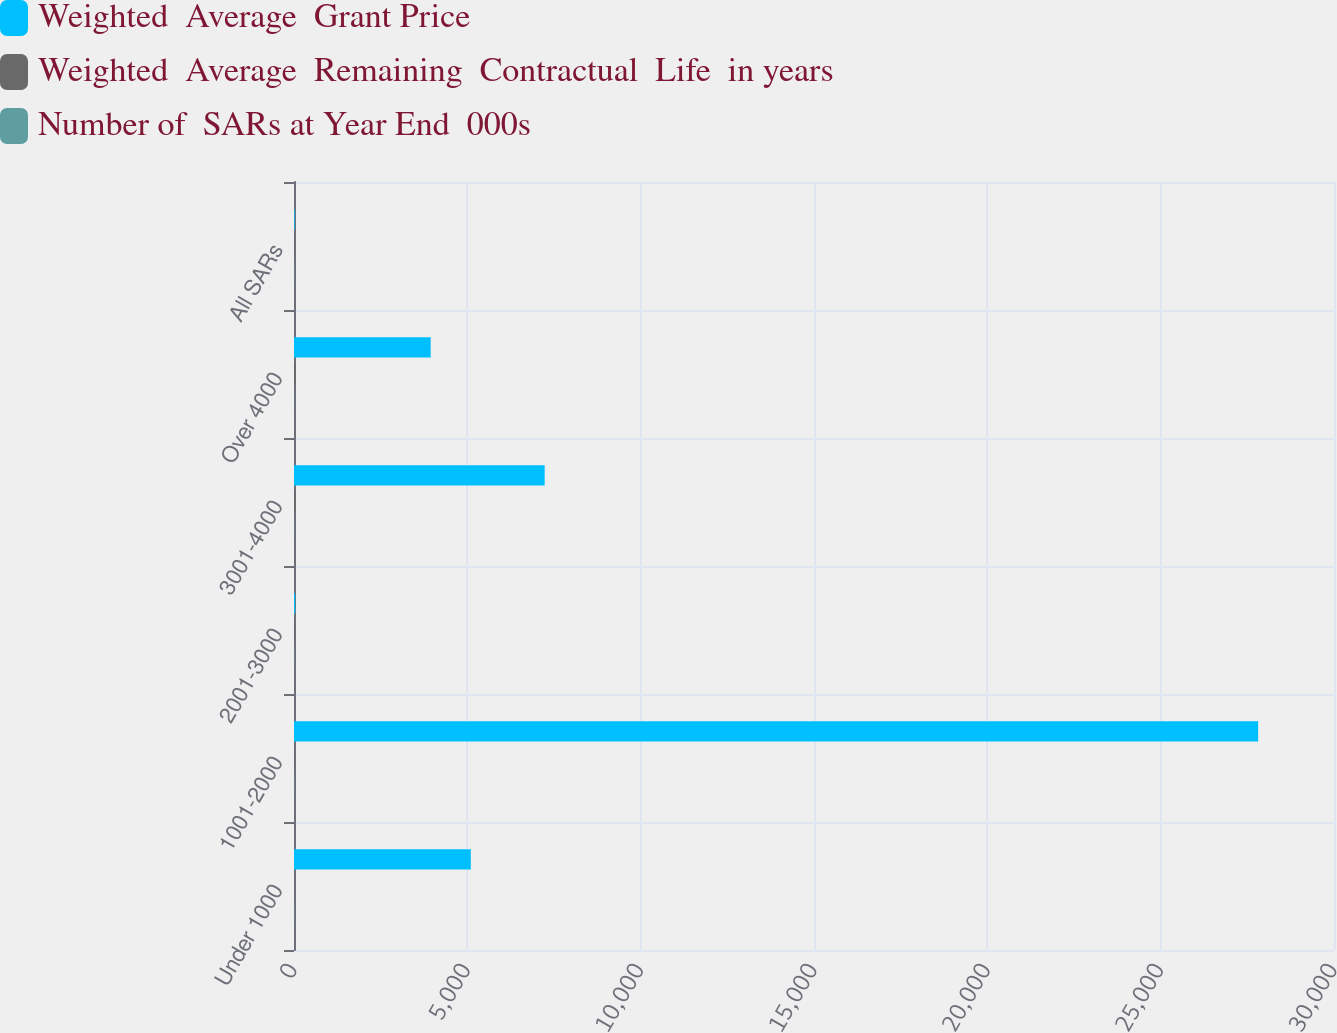<chart> <loc_0><loc_0><loc_500><loc_500><stacked_bar_chart><ecel><fcel>Under 1000<fcel>1001-2000<fcel>2001-3000<fcel>3001-4000<fcel>Over 4000<fcel>All SARs<nl><fcel>Weighted  Average  Grant Price<fcel>5100<fcel>27812<fcel>34<fcel>7231<fcel>3943<fcel>20.41<nl><fcel>Weighted  Average  Remaining  Contractual  Life  in years<fcel>4.06<fcel>14.98<fcel>22.88<fcel>38.69<fcel>46.37<fcel>20.41<nl><fcel>Number of  SARs at Year End  000s<fcel>6.3<fcel>8<fcel>5.2<fcel>3.6<fcel>2.2<fcel>6.6<nl></chart> 